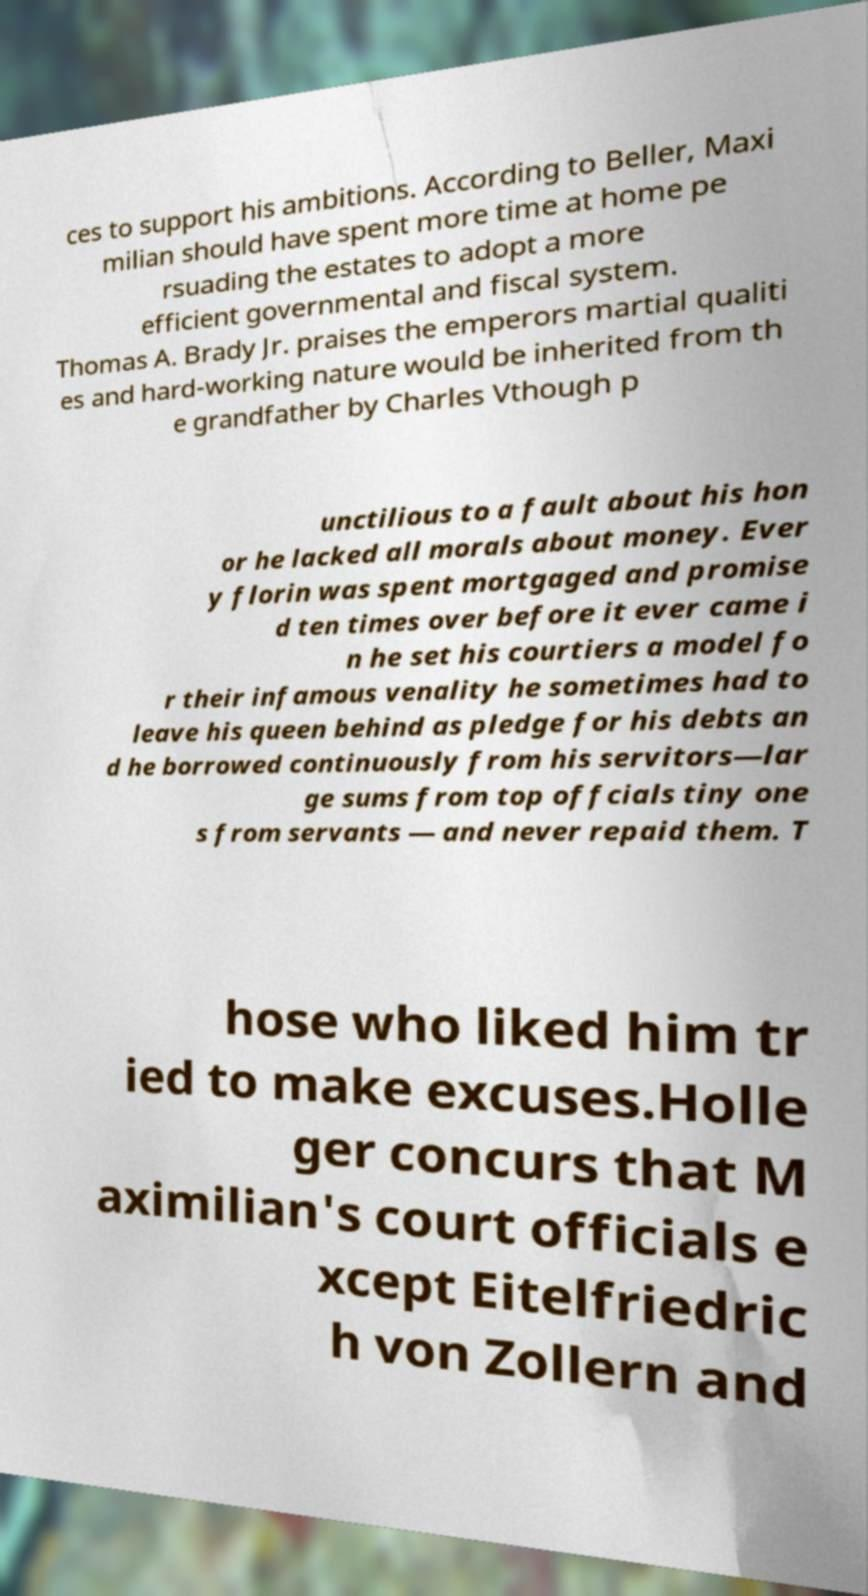Please read and relay the text visible in this image. What does it say? ces to support his ambitions. According to Beller, Maxi milian should have spent more time at home pe rsuading the estates to adopt a more efficient governmental and fiscal system. Thomas A. Brady Jr. praises the emperors martial qualiti es and hard-working nature would be inherited from th e grandfather by Charles Vthough p unctilious to a fault about his hon or he lacked all morals about money. Ever y florin was spent mortgaged and promise d ten times over before it ever came i n he set his courtiers a model fo r their infamous venality he sometimes had to leave his queen behind as pledge for his debts an d he borrowed continuously from his servitors—lar ge sums from top offcials tiny one s from servants — and never repaid them. T hose who liked him tr ied to make excuses.Holle ger concurs that M aximilian's court officials e xcept Eitelfriedric h von Zollern and 